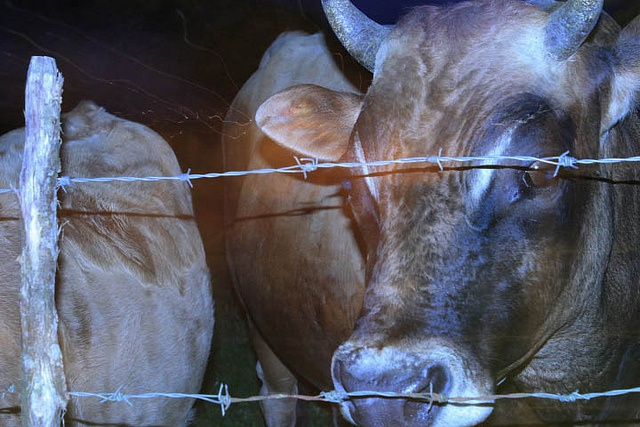Describe the objects in this image and their specific colors. I can see cow in black and gray tones and cow in black and gray tones in this image. 